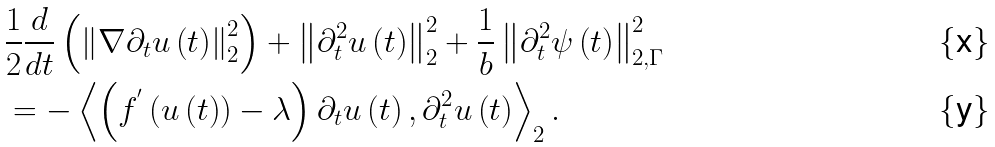<formula> <loc_0><loc_0><loc_500><loc_500>& \frac { 1 } { 2 } \frac { d } { d t } \left ( \left \| \nabla \partial _ { t } u \left ( t \right ) \right \| _ { 2 } ^ { 2 } \right ) + \left \| \partial _ { t } ^ { 2 } u \left ( t \right ) \right \| _ { 2 } ^ { 2 } + \frac { 1 } { b } \left \| \partial _ { t } ^ { 2 } \psi \left ( t \right ) \right \| _ { 2 , \Gamma } ^ { 2 } \\ & = - \left \langle \left ( f ^ { ^ { \prime } } \left ( u \left ( t \right ) \right ) - \lambda \right ) \partial _ { t } u \left ( t \right ) , \partial _ { t } ^ { 2 } u \left ( t \right ) \right \rangle _ { 2 } .</formula> 